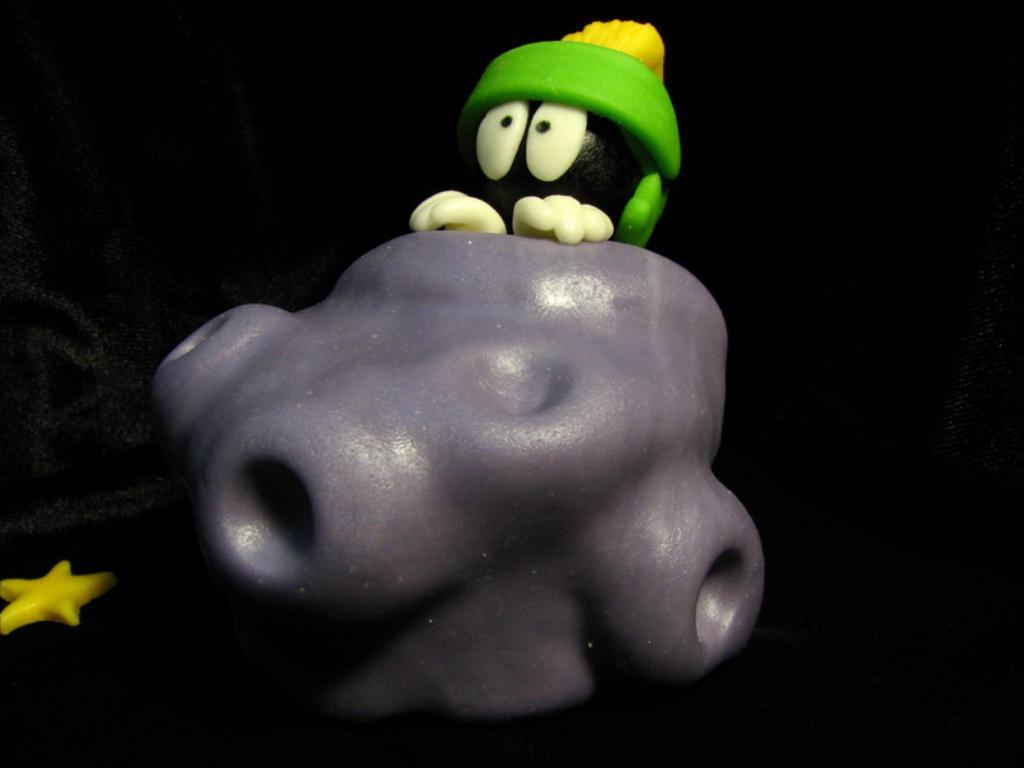What is the main object in the image? There is a toy in the image. Can you describe the appearance of the toy? The toy has different colors. Where is the toy located in the image? The toy is in the center of the image. What type of apple is being used as a prop in the image? There is no apple present in the image; it features a toy with different colors. What is the chance of the toy sliding down a slope in the image? There is no slope present in the image, so the chance of the toy sliding down a slope cannot be determined. 